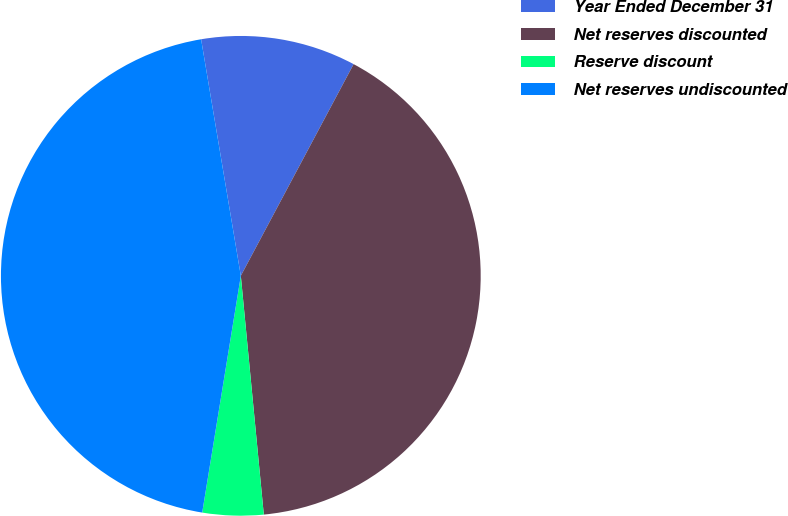<chart> <loc_0><loc_0><loc_500><loc_500><pie_chart><fcel>Year Ended December 31<fcel>Net reserves discounted<fcel>Reserve discount<fcel>Net reserves undiscounted<nl><fcel>10.44%<fcel>40.68%<fcel>4.1%<fcel>44.78%<nl></chart> 